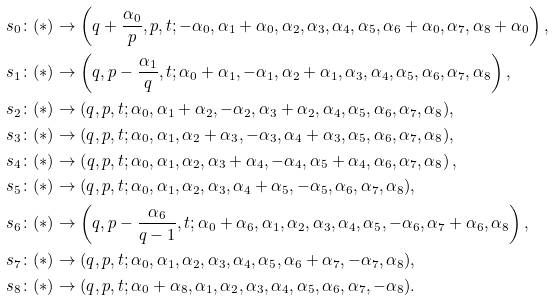<formula> <loc_0><loc_0><loc_500><loc_500>s _ { 0 } \colon ( * ) & \rightarrow \left ( q + \frac { \alpha _ { 0 } } { p } , p , t ; - \alpha _ { 0 } , \alpha _ { 1 } + \alpha _ { 0 } , \alpha _ { 2 } , \alpha _ { 3 } , \alpha _ { 4 } , \alpha _ { 5 } , \alpha _ { 6 } + \alpha _ { 0 } , \alpha _ { 7 } , \alpha _ { 8 } + \alpha _ { 0 } \right ) , \\ s _ { 1 } \colon ( * ) & \rightarrow \left ( q , p - \frac { \alpha _ { 1 } } { q } , t ; \alpha _ { 0 } + \alpha _ { 1 } , - \alpha _ { 1 } , \alpha _ { 2 } + \alpha _ { 1 } , \alpha _ { 3 } , \alpha _ { 4 } , \alpha _ { 5 } , \alpha _ { 6 } , \alpha _ { 7 } , \alpha _ { 8 } \right ) , \\ s _ { 2 } \colon ( * ) & \rightarrow ( q , p , t ; \alpha _ { 0 } , \alpha _ { 1 } + \alpha _ { 2 } , - \alpha _ { 2 } , \alpha _ { 3 } + \alpha _ { 2 } , \alpha _ { 4 } , \alpha _ { 5 } , \alpha _ { 6 } , \alpha _ { 7 } , \alpha _ { 8 } ) , \\ s _ { 3 } \colon ( * ) & \rightarrow ( q , p , t ; \alpha _ { 0 } , \alpha _ { 1 } , \alpha _ { 2 } + \alpha _ { 3 } , - \alpha _ { 3 } , \alpha _ { 4 } + \alpha _ { 3 } , \alpha _ { 5 } , \alpha _ { 6 } , \alpha _ { 7 } , \alpha _ { 8 } ) , \\ s _ { 4 } \colon ( * ) & \rightarrow \left ( q , p , t ; \alpha _ { 0 } , \alpha _ { 1 } , \alpha _ { 2 } , \alpha _ { 3 } + \alpha _ { 4 } , - \alpha _ { 4 } , \alpha _ { 5 } + \alpha _ { 4 } , \alpha _ { 6 } , \alpha _ { 7 } , \alpha _ { 8 } \right ) , \\ s _ { 5 } \colon ( * ) & \rightarrow ( q , p , t ; \alpha _ { 0 } , \alpha _ { 1 } , \alpha _ { 2 } , \alpha _ { 3 } , \alpha _ { 4 } + \alpha _ { 5 } , - \alpha _ { 5 } , \alpha _ { 6 } , \alpha _ { 7 } , \alpha _ { 8 } ) , \\ s _ { 6 } \colon ( * ) & \rightarrow \left ( q , p - \frac { \alpha _ { 6 } } { q - 1 } , t ; \alpha _ { 0 } + \alpha _ { 6 } , \alpha _ { 1 } , \alpha _ { 2 } , \alpha _ { 3 } , \alpha _ { 4 } , \alpha _ { 5 } , - \alpha _ { 6 } , \alpha _ { 7 } + \alpha _ { 6 } , \alpha _ { 8 } \right ) , \\ s _ { 7 } \colon ( * ) & \rightarrow ( q , p , t ; \alpha _ { 0 } , \alpha _ { 1 } , \alpha _ { 2 } , \alpha _ { 3 } , \alpha _ { 4 } , \alpha _ { 5 } , \alpha _ { 6 } + \alpha _ { 7 } , - \alpha _ { 7 } , \alpha _ { 8 } ) , \\ s _ { 8 } \colon ( * ) & \rightarrow ( q , p , t ; \alpha _ { 0 } + \alpha _ { 8 } , \alpha _ { 1 } , \alpha _ { 2 } , \alpha _ { 3 } , \alpha _ { 4 } , \alpha _ { 5 } , \alpha _ { 6 } , \alpha _ { 7 } , - \alpha _ { 8 } ) .</formula> 